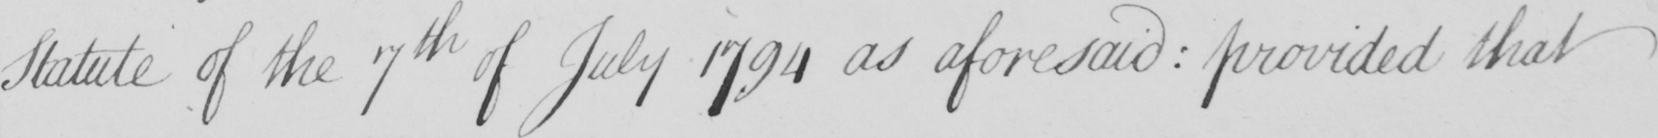Please provide the text content of this handwritten line. Statute of the 7th of July 1794 as aforesaid  :  provided that 